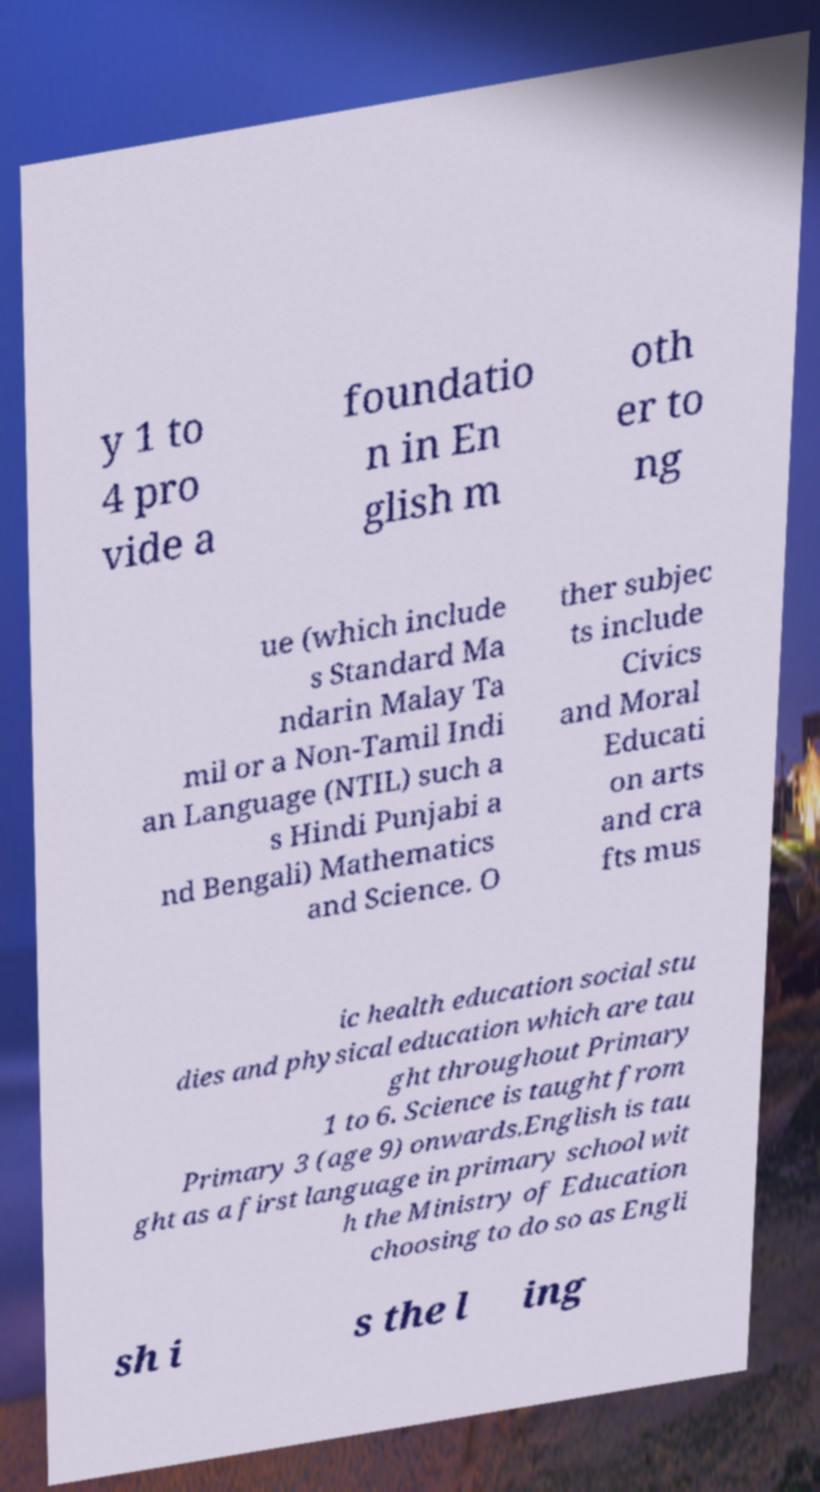Please read and relay the text visible in this image. What does it say? y 1 to 4 pro vide a foundatio n in En glish m oth er to ng ue (which include s Standard Ma ndarin Malay Ta mil or a Non-Tamil Indi an Language (NTIL) such a s Hindi Punjabi a nd Bengali) Mathematics and Science. O ther subjec ts include Civics and Moral Educati on arts and cra fts mus ic health education social stu dies and physical education which are tau ght throughout Primary 1 to 6. Science is taught from Primary 3 (age 9) onwards.English is tau ght as a first language in primary school wit h the Ministry of Education choosing to do so as Engli sh i s the l ing 